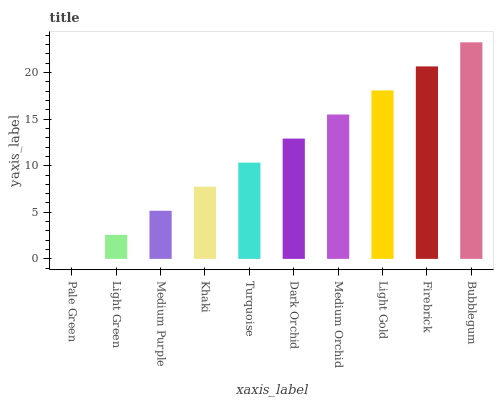Is Pale Green the minimum?
Answer yes or no. Yes. Is Bubblegum the maximum?
Answer yes or no. Yes. Is Light Green the minimum?
Answer yes or no. No. Is Light Green the maximum?
Answer yes or no. No. Is Light Green greater than Pale Green?
Answer yes or no. Yes. Is Pale Green less than Light Green?
Answer yes or no. Yes. Is Pale Green greater than Light Green?
Answer yes or no. No. Is Light Green less than Pale Green?
Answer yes or no. No. Is Dark Orchid the high median?
Answer yes or no. Yes. Is Turquoise the low median?
Answer yes or no. Yes. Is Medium Purple the high median?
Answer yes or no. No. Is Medium Purple the low median?
Answer yes or no. No. 